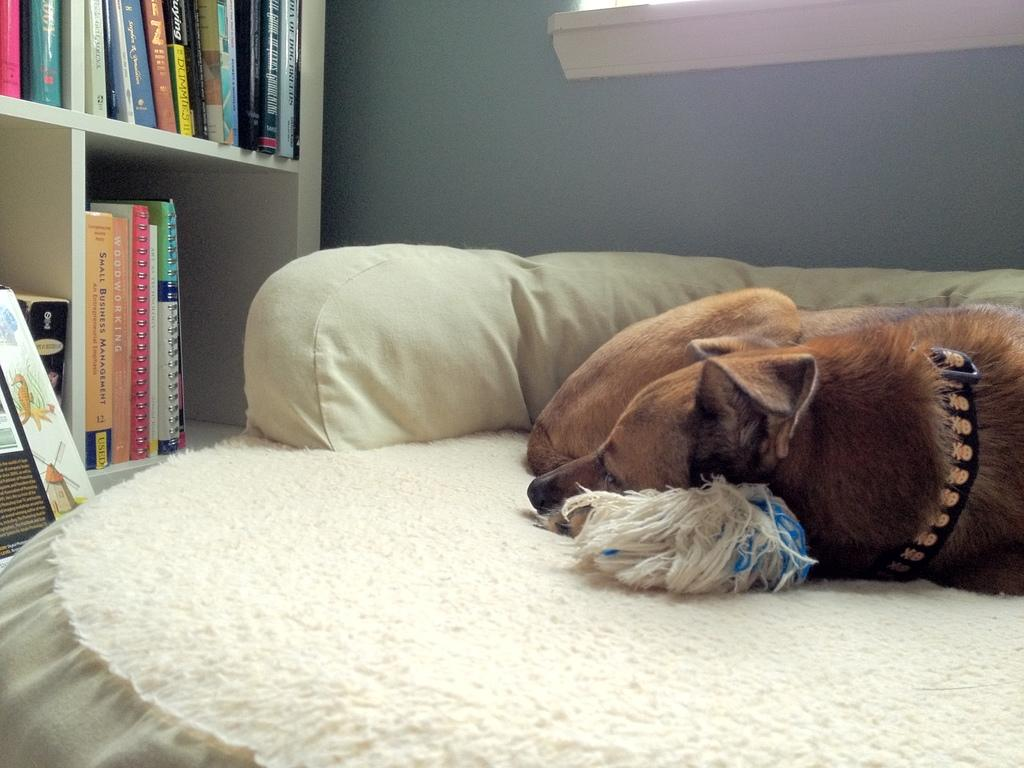What animal can be seen in the image? There is a dog lying on the bed. What objects are in the background of the image? There are books in the rack and a light in the background. What type of structure is visible in the background? There is a wall in the background. What type of airplane is flying in harmony with the dog in the image? There is no airplane present in the image, and the dog is lying on the bed, not flying in harmony with any aircraft. 